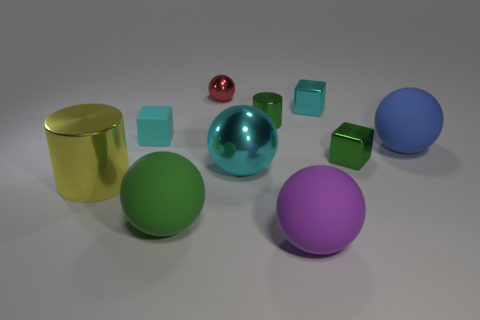There is a shiny sphere that is the same size as the yellow metal thing; what is its color?
Provide a short and direct response. Cyan. Is there a small metallic ball of the same color as the big metallic ball?
Your answer should be very brief. No. What is the material of the purple thing?
Your response must be concise. Rubber. How many large red blocks are there?
Make the answer very short. 0. Is the color of the metallic cylinder on the right side of the cyan rubber thing the same as the small block that is on the left side of the green rubber object?
Ensure brevity in your answer.  No. What is the size of the metal thing that is the same color as the small shiny cylinder?
Provide a succinct answer. Small. How many other objects are the same size as the red ball?
Provide a short and direct response. 4. The block that is behind the rubber cube is what color?
Your answer should be very brief. Cyan. Is the material of the block left of the green cylinder the same as the purple thing?
Give a very brief answer. Yes. How many green objects are both in front of the tiny green cylinder and behind the large yellow shiny object?
Offer a very short reply. 1. 